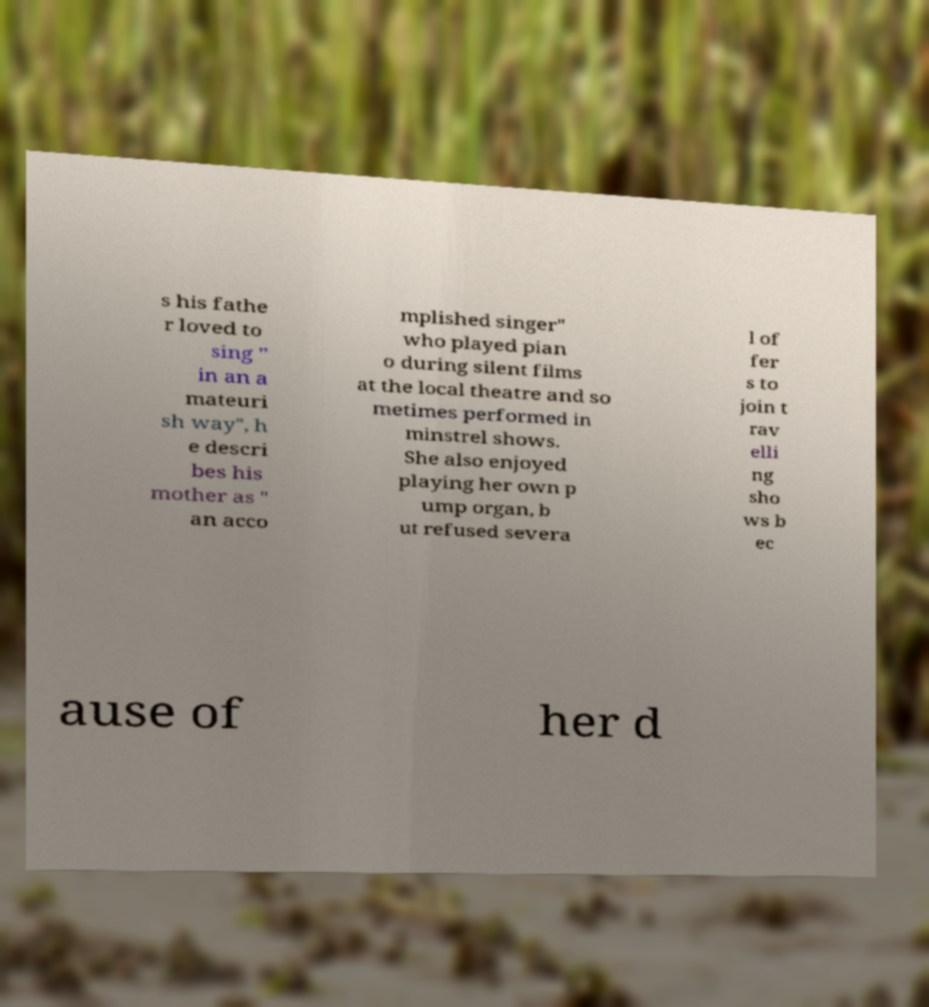There's text embedded in this image that I need extracted. Can you transcribe it verbatim? s his fathe r loved to sing " in an a mateuri sh way", h e descri bes his mother as " an acco mplished singer" who played pian o during silent films at the local theatre and so metimes performed in minstrel shows. She also enjoyed playing her own p ump organ, b ut refused severa l of fer s to join t rav elli ng sho ws b ec ause of her d 